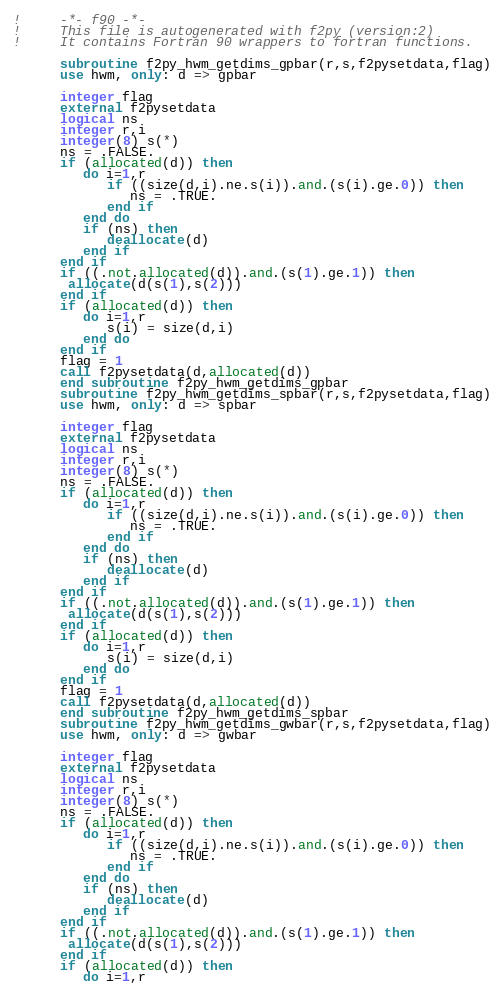Convert code to text. <code><loc_0><loc_0><loc_500><loc_500><_FORTRAN_>!     -*- f90 -*-
!     This file is autogenerated with f2py (version:2)
!     It contains Fortran 90 wrappers to fortran functions.

      subroutine f2py_hwm_getdims_gpbar(r,s,f2pysetdata,flag)
      use hwm, only: d => gpbar

      integer flag
      external f2pysetdata
      logical ns
      integer r,i
      integer(8) s(*)
      ns = .FALSE.
      if (allocated(d)) then
         do i=1,r
            if ((size(d,i).ne.s(i)).and.(s(i).ge.0)) then
               ns = .TRUE.
            end if
         end do
         if (ns) then
            deallocate(d)
         end if
      end if
      if ((.not.allocated(d)).and.(s(1).ge.1)) then
       allocate(d(s(1),s(2)))
      end if
      if (allocated(d)) then
         do i=1,r
            s(i) = size(d,i)
         end do
      end if
      flag = 1
      call f2pysetdata(d,allocated(d))
      end subroutine f2py_hwm_getdims_gpbar
      subroutine f2py_hwm_getdims_spbar(r,s,f2pysetdata,flag)
      use hwm, only: d => spbar

      integer flag
      external f2pysetdata
      logical ns
      integer r,i
      integer(8) s(*)
      ns = .FALSE.
      if (allocated(d)) then
         do i=1,r
            if ((size(d,i).ne.s(i)).and.(s(i).ge.0)) then
               ns = .TRUE.
            end if
         end do
         if (ns) then
            deallocate(d)
         end if
      end if
      if ((.not.allocated(d)).and.(s(1).ge.1)) then
       allocate(d(s(1),s(2)))
      end if
      if (allocated(d)) then
         do i=1,r
            s(i) = size(d,i)
         end do
      end if
      flag = 1
      call f2pysetdata(d,allocated(d))
      end subroutine f2py_hwm_getdims_spbar
      subroutine f2py_hwm_getdims_gwbar(r,s,f2pysetdata,flag)
      use hwm, only: d => gwbar

      integer flag
      external f2pysetdata
      logical ns
      integer r,i
      integer(8) s(*)
      ns = .FALSE.
      if (allocated(d)) then
         do i=1,r
            if ((size(d,i).ne.s(i)).and.(s(i).ge.0)) then
               ns = .TRUE.
            end if
         end do
         if (ns) then
            deallocate(d)
         end if
      end if
      if ((.not.allocated(d)).and.(s(1).ge.1)) then
       allocate(d(s(1),s(2)))
      end if
      if (allocated(d)) then
         do i=1,r</code> 